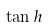Convert formula to latex. <formula><loc_0><loc_0><loc_500><loc_500>\tan h</formula> 